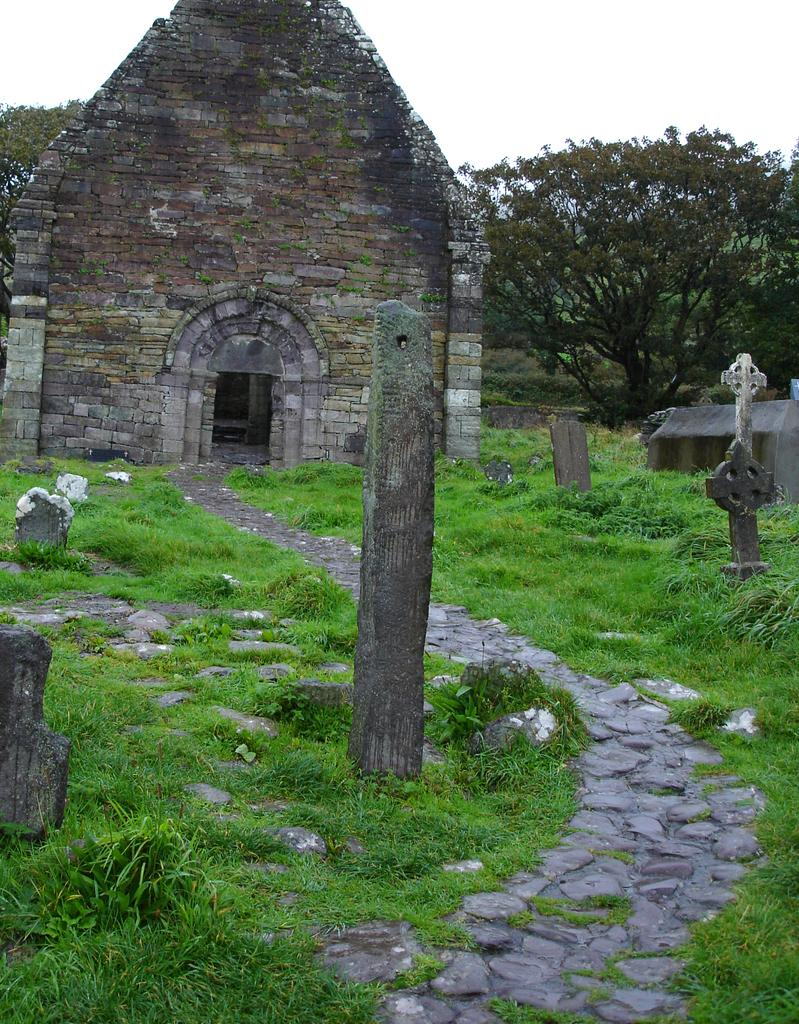What type of structure is visible in the image? There is a stone wall in the image. What else can be seen in the image besides the stone wall? There is a pole, grass, stones, and trees in the background of the image. What is the ground covered with in the image? The ground is covered with grass in the image. What is visible in the background of the image? There are trees and the sky visible in the background of the image. What type of cake is being served on the stone wall in the image? There is no cake present in the image; it features a stone wall, a pole, grass, stones, trees, and the sky. 